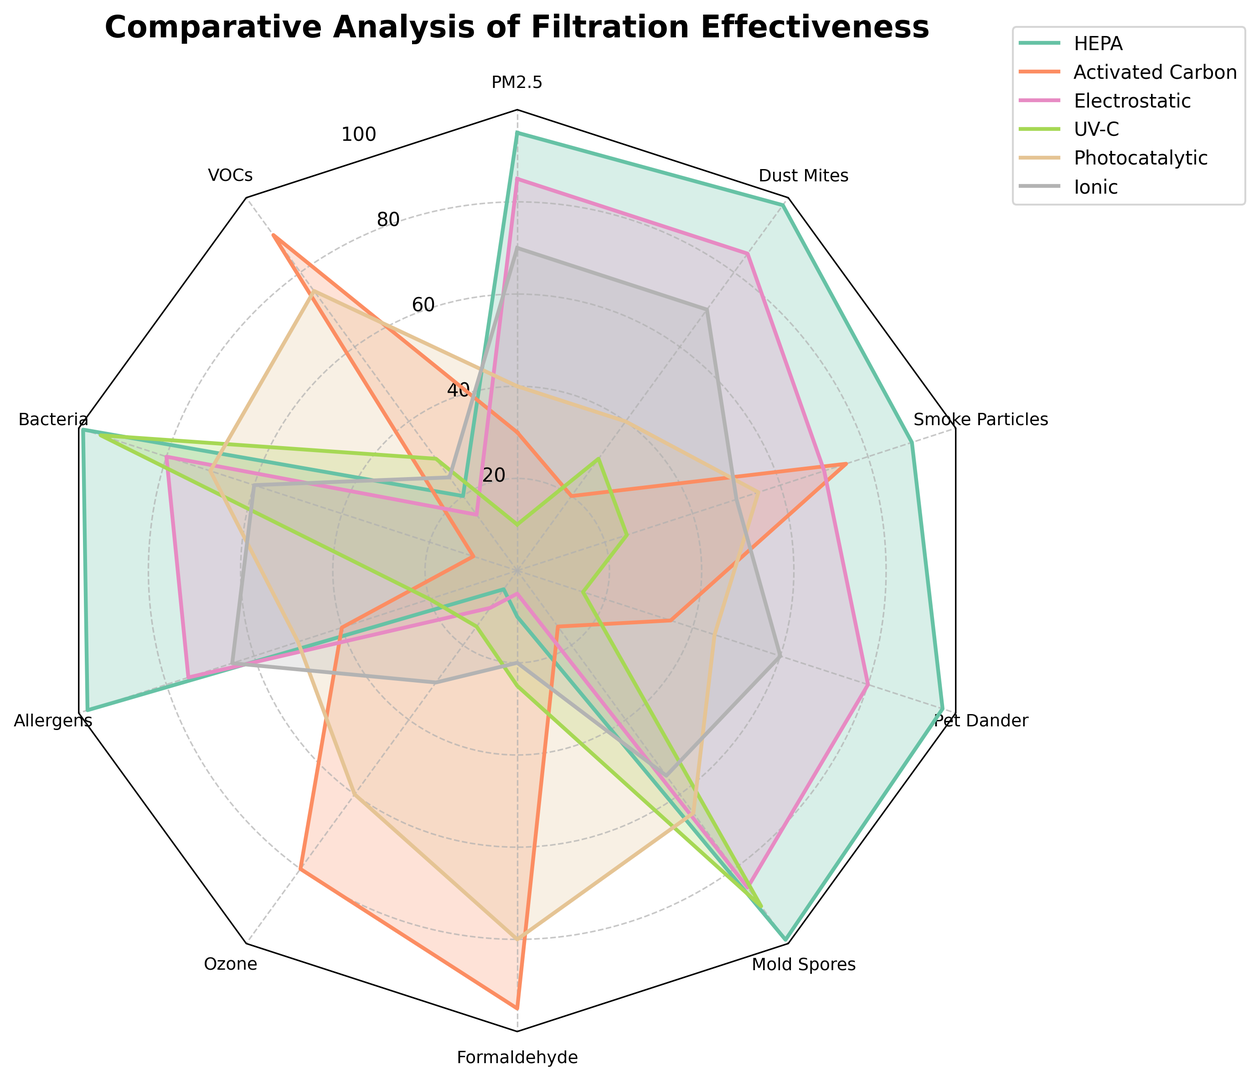Which filtration method is most effective against bacteria? To find the most effective filtration method against bacteria, look for the filtration method with the highest value in the "Bacteria" segment of the radar chart. According to the chart, the value for "Bacteria" is highest for UV-C at 95.
Answer: UV-C Which filter is less effective overall, Ionic or Electrostatic? To determine which filter is less effective overall, you need to compare the average scores of Ionic and Electrostatic across all pollutants. From the radar chart, tally the values for each filter and calculate the averages. For Ionic: (70 + 25 + 60 + 65 + 30 + 20 + 55 + 60 + 50 + 70) / 10 = 50.5. For Electrostatic: (85 + 15 + 80 + 75 + 10 + 5 + 85 + 80 + 70 + 85) / 10 = 59.5. Electrostatic has a higher average score, making Ionic the less effective filter overall.
Answer: Ionic Compare the effectiveness of HEPA and Photocatalytic against allergens and dust mites. Look at the "Allergens" and "Dust Mites" values for HEPA and Photocatalytic in the radar chart. HEPA's effectiveness against Allergens is 98, and against Dust Mites is 98. Photocatalytic's effectiveness against Allergens is 50, and against Dust Mites is 40. Thus, HEPA is more effective against both allergens and dust mites.
Answer: HEPA How does the effectiveness of Activated Carbon compare against Electrostatic in removing formaldehyde? Check the values for "Formaldehyde" for both Activated Carbon and Electrostatic. Activated Carbon has a value of 95, while Electrostatic has a value of 5. Therefore, Activated Carbon is significantly more effective in removing formaldehyde than Electrostatic.
Answer: Activated Carbon Which filtration method shows the highest variance in effectiveness across all pollutants? To determine the highest variance, calculate the variance of each filter's effectiveness scores across all pollutants. The filter with the widest range between its lowest and highest values indicates high variance. HEPA ranges from 5 to 99, Activated Carbon from 10 to 95, Electrostatic from 5 to 85, UV-C from 10 to 95, Photocatalytic from 40 to 80, and Ionic from 20 to 70. HEPA shows the highest variance.
Answer: HEPA Which filtration method is least effective at removing ozone? Check the "Ozone" segment to identify the method with the lowest value. HEPA has a value of 5, Activated Carbon 80, Electrostatic 10, UV-C 15, Photocatalytic 60, and Ionic 30. Thus, HEPA is the least effective at removing ozone.
Answer: HEPA 